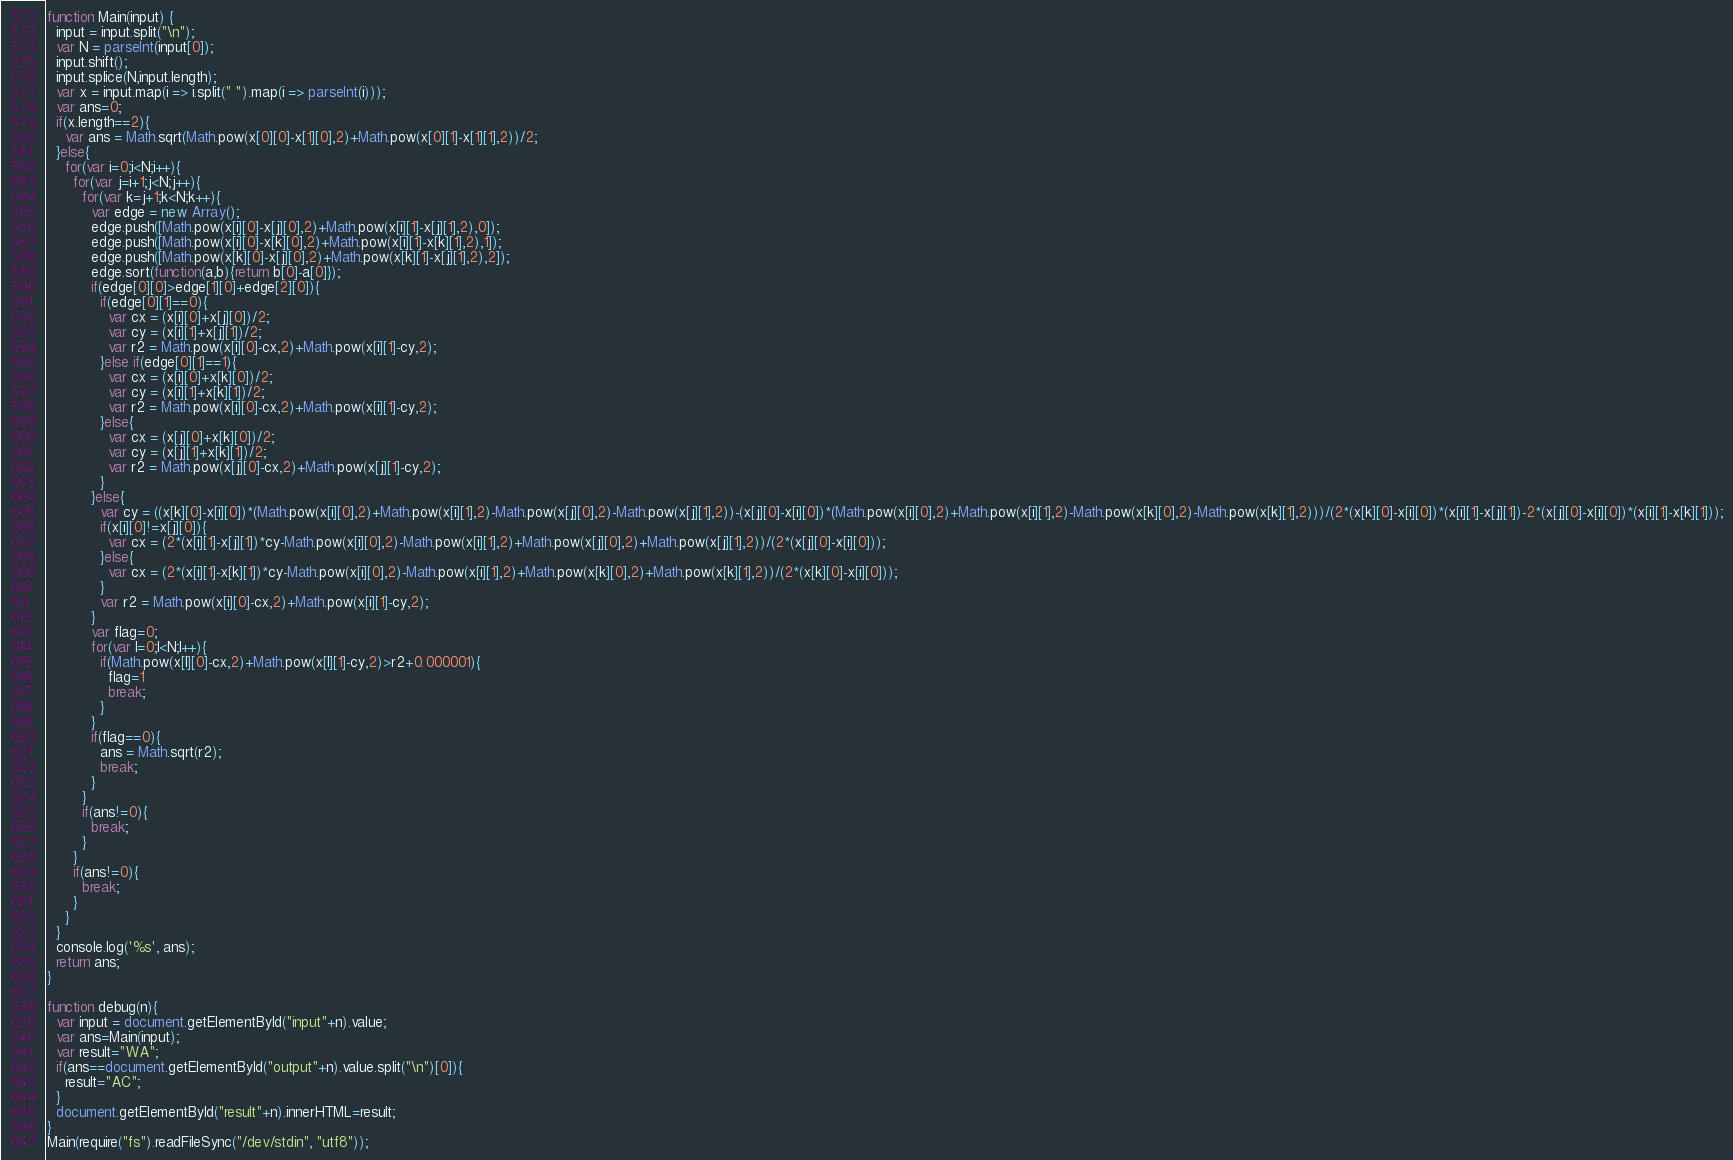<code> <loc_0><loc_0><loc_500><loc_500><_JavaScript_>function Main(input) {
  input = input.split("\n");
  var N = parseInt(input[0]);
  input.shift();
  input.splice(N,input.length);
  var x = input.map(i => i.split(" ").map(i => parseInt(i)));
  var ans=0;
  if(x.length==2){
    var ans = Math.sqrt(Math.pow(x[0][0]-x[1][0],2)+Math.pow(x[0][1]-x[1][1],2))/2;
  }else{
    for(var i=0;i<N;i++){
      for(var j=i+1;j<N;j++){
        for(var k=j+1;k<N;k++){
          var edge = new Array();
          edge.push([Math.pow(x[i][0]-x[j][0],2)+Math.pow(x[i][1]-x[j][1],2),0]);
          edge.push([Math.pow(x[i][0]-x[k][0],2)+Math.pow(x[i][1]-x[k][1],2),1]);
          edge.push([Math.pow(x[k][0]-x[j][0],2)+Math.pow(x[k][1]-x[j][1],2),2]);
          edge.sort(function(a,b){return b[0]-a[0]});
          if(edge[0][0]>edge[1][0]+edge[2][0]){
            if(edge[0][1]==0){
              var cx = (x[i][0]+x[j][0])/2;
              var cy = (x[i][1]+x[j][1])/2;
              var r2 = Math.pow(x[i][0]-cx,2)+Math.pow(x[i][1]-cy,2);
            }else if(edge[0][1]==1){
              var cx = (x[i][0]+x[k][0])/2;
              var cy = (x[i][1]+x[k][1])/2;
              var r2 = Math.pow(x[i][0]-cx,2)+Math.pow(x[i][1]-cy,2);
            }else{
              var cx = (x[j][0]+x[k][0])/2;
              var cy = (x[j][1]+x[k][1])/2;
              var r2 = Math.pow(x[j][0]-cx,2)+Math.pow(x[j][1]-cy,2);
            }
          }else{
            var cy = ((x[k][0]-x[i][0])*(Math.pow(x[i][0],2)+Math.pow(x[i][1],2)-Math.pow(x[j][0],2)-Math.pow(x[j][1],2))-(x[j][0]-x[i][0])*(Math.pow(x[i][0],2)+Math.pow(x[i][1],2)-Math.pow(x[k][0],2)-Math.pow(x[k][1],2)))/(2*(x[k][0]-x[i][0])*(x[i][1]-x[j][1])-2*(x[j][0]-x[i][0])*(x[i][1]-x[k][1]));
            if(x[i][0]!=x[j][0]){
              var cx = (2*(x[i][1]-x[j][1])*cy-Math.pow(x[i][0],2)-Math.pow(x[i][1],2)+Math.pow(x[j][0],2)+Math.pow(x[j][1],2))/(2*(x[j][0]-x[i][0]));
            }else{
              var cx = (2*(x[i][1]-x[k][1])*cy-Math.pow(x[i][0],2)-Math.pow(x[i][1],2)+Math.pow(x[k][0],2)+Math.pow(x[k][1],2))/(2*(x[k][0]-x[i][0]));
            }
            var r2 = Math.pow(x[i][0]-cx,2)+Math.pow(x[i][1]-cy,2);
          }
          var flag=0;
          for(var l=0;l<N;l++){
            if(Math.pow(x[l][0]-cx,2)+Math.pow(x[l][1]-cy,2)>r2+0.000001){
              flag=1
              break;
            }
          }
          if(flag==0){
            ans = Math.sqrt(r2);
            break;
          }
        }
        if(ans!=0){
          break;
        }
      }
      if(ans!=0){
        break;
      }
    }
  }
  console.log('%s', ans);
  return ans;
}

function debug(n){
  var input = document.getElementById("input"+n).value;
  var ans=Main(input);
  var result="WA";
  if(ans==document.getElementById("output"+n).value.split("\n")[0]){
    result="AC";
  }
  document.getElementById("result"+n).innerHTML=result;
}
Main(require("fs").readFileSync("/dev/stdin", "utf8"));</code> 